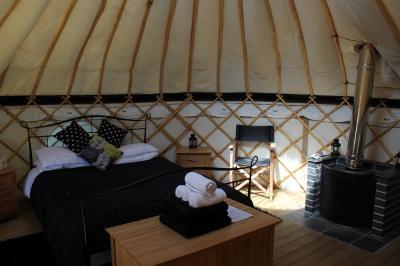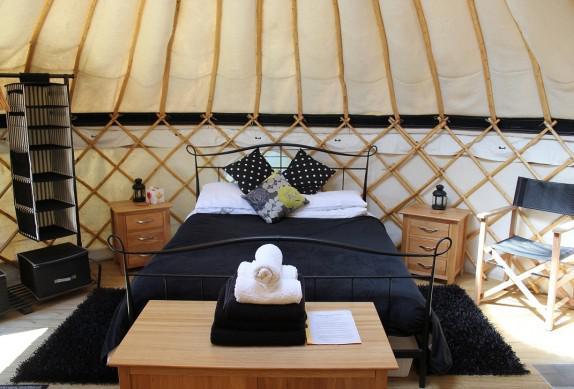The first image is the image on the left, the second image is the image on the right. Assess this claim about the two images: "Left and right images feature a bedroom inside a yurt, and at least one bedroom features a bed flanked by wooden nightstands.". Correct or not? Answer yes or no. Yes. The first image is the image on the left, the second image is the image on the right. Assess this claim about the two images: "The door opens to the living area of the yurt in one of the images.". Correct or not? Answer yes or no. No. 